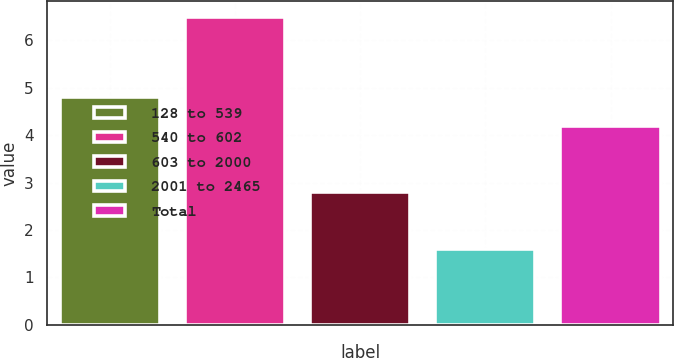Convert chart. <chart><loc_0><loc_0><loc_500><loc_500><bar_chart><fcel>128 to 539<fcel>540 to 602<fcel>603 to 2000<fcel>2001 to 2465<fcel>Total<nl><fcel>4.8<fcel>6.5<fcel>2.8<fcel>1.6<fcel>4.2<nl></chart> 